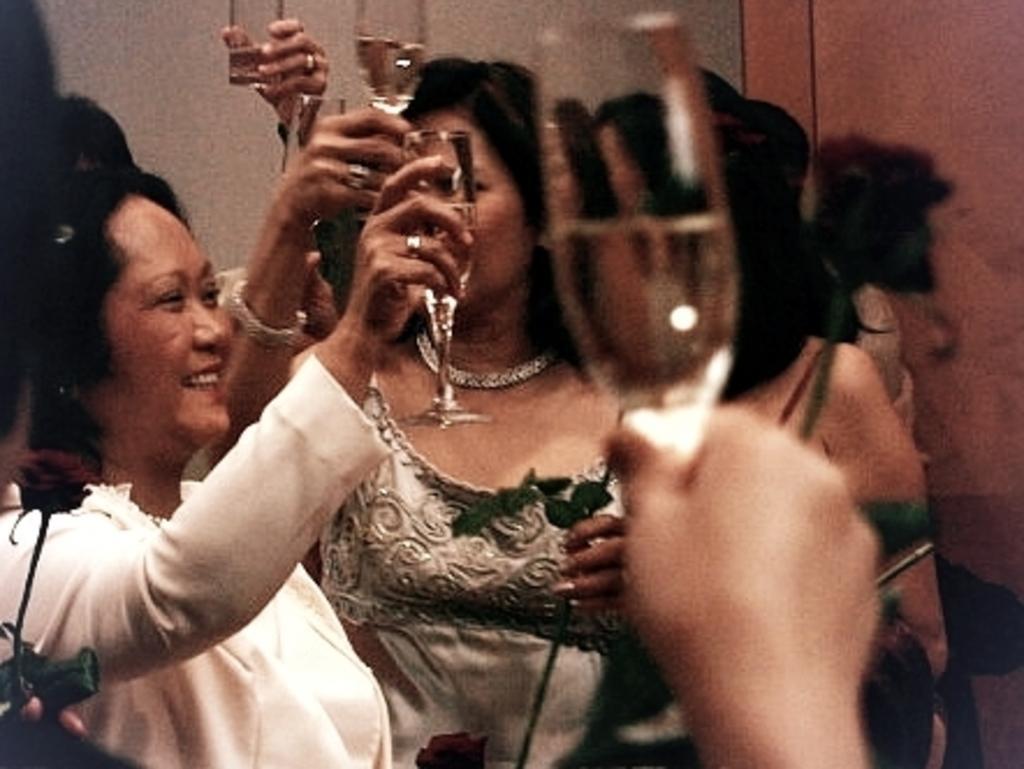Describe this image in one or two sentences. This picture shows some women smiling and holding glasses in their hands and in the background there is a wall. 